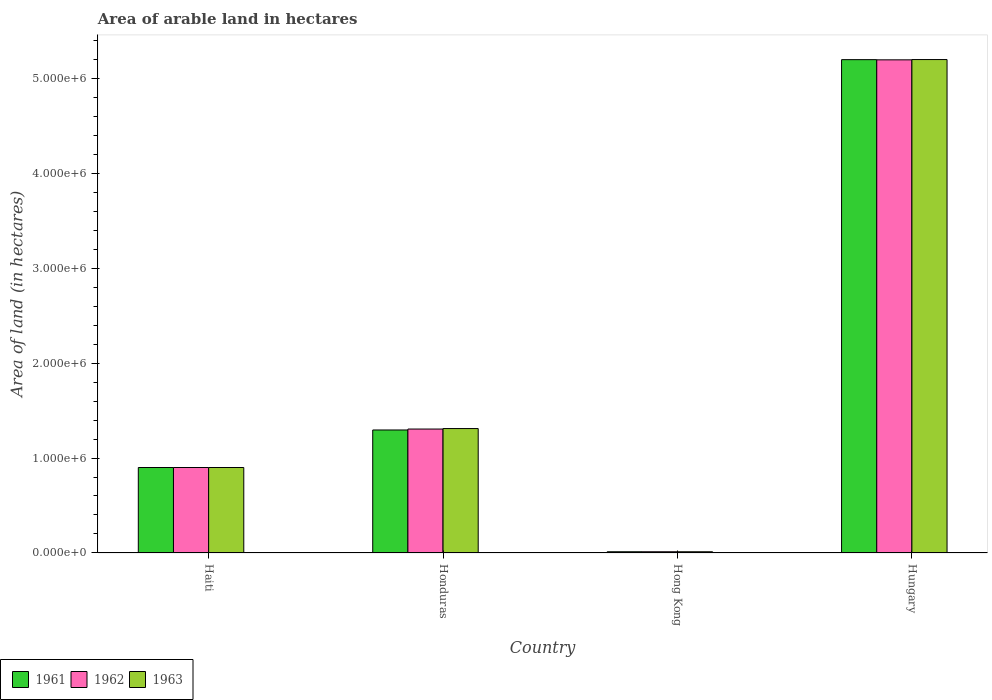How many different coloured bars are there?
Your answer should be very brief. 3. How many bars are there on the 4th tick from the left?
Ensure brevity in your answer.  3. What is the label of the 4th group of bars from the left?
Provide a short and direct response. Hungary. In how many cases, is the number of bars for a given country not equal to the number of legend labels?
Make the answer very short. 0. What is the total arable land in 1961 in Hong Kong?
Provide a succinct answer. 1.30e+04. Across all countries, what is the maximum total arable land in 1961?
Keep it short and to the point. 5.19e+06. Across all countries, what is the minimum total arable land in 1963?
Your answer should be very brief. 1.30e+04. In which country was the total arable land in 1963 maximum?
Provide a short and direct response. Hungary. In which country was the total arable land in 1961 minimum?
Your answer should be compact. Hong Kong. What is the total total arable land in 1961 in the graph?
Your answer should be very brief. 7.40e+06. What is the difference between the total arable land in 1961 in Hong Kong and that in Hungary?
Make the answer very short. -5.18e+06. What is the difference between the total arable land in 1962 in Hong Kong and the total arable land in 1961 in Hungary?
Your response must be concise. -5.18e+06. What is the average total arable land in 1962 per country?
Offer a terse response. 1.85e+06. What is the difference between the total arable land of/in 1961 and total arable land of/in 1963 in Hungary?
Your response must be concise. -1000. In how many countries, is the total arable land in 1963 greater than 2600000 hectares?
Ensure brevity in your answer.  1. What is the ratio of the total arable land in 1961 in Hong Kong to that in Hungary?
Offer a very short reply. 0. Is the total arable land in 1963 in Honduras less than that in Hungary?
Your answer should be very brief. Yes. What is the difference between the highest and the second highest total arable land in 1961?
Give a very brief answer. 3.90e+06. What is the difference between the highest and the lowest total arable land in 1962?
Offer a terse response. 5.18e+06. Is the sum of the total arable land in 1962 in Haiti and Hungary greater than the maximum total arable land in 1963 across all countries?
Give a very brief answer. Yes. What does the 2nd bar from the left in Hungary represents?
Ensure brevity in your answer.  1962. Is it the case that in every country, the sum of the total arable land in 1962 and total arable land in 1961 is greater than the total arable land in 1963?
Your answer should be compact. Yes. Are all the bars in the graph horizontal?
Your answer should be very brief. No. What is the difference between two consecutive major ticks on the Y-axis?
Provide a succinct answer. 1.00e+06. Does the graph contain grids?
Offer a terse response. No. How many legend labels are there?
Provide a succinct answer. 3. How are the legend labels stacked?
Your answer should be very brief. Horizontal. What is the title of the graph?
Your answer should be very brief. Area of arable land in hectares. What is the label or title of the X-axis?
Your answer should be very brief. Country. What is the label or title of the Y-axis?
Your answer should be very brief. Area of land (in hectares). What is the Area of land (in hectares) in 1962 in Haiti?
Your answer should be compact. 9.00e+05. What is the Area of land (in hectares) of 1961 in Honduras?
Your answer should be compact. 1.30e+06. What is the Area of land (in hectares) of 1962 in Honduras?
Provide a succinct answer. 1.30e+06. What is the Area of land (in hectares) of 1963 in Honduras?
Keep it short and to the point. 1.31e+06. What is the Area of land (in hectares) of 1961 in Hong Kong?
Offer a very short reply. 1.30e+04. What is the Area of land (in hectares) in 1962 in Hong Kong?
Offer a very short reply. 1.30e+04. What is the Area of land (in hectares) of 1963 in Hong Kong?
Give a very brief answer. 1.30e+04. What is the Area of land (in hectares) in 1961 in Hungary?
Ensure brevity in your answer.  5.19e+06. What is the Area of land (in hectares) in 1962 in Hungary?
Offer a very short reply. 5.19e+06. What is the Area of land (in hectares) in 1963 in Hungary?
Provide a short and direct response. 5.20e+06. Across all countries, what is the maximum Area of land (in hectares) in 1961?
Your answer should be very brief. 5.19e+06. Across all countries, what is the maximum Area of land (in hectares) in 1962?
Your answer should be very brief. 5.19e+06. Across all countries, what is the maximum Area of land (in hectares) of 1963?
Make the answer very short. 5.20e+06. Across all countries, what is the minimum Area of land (in hectares) of 1961?
Your response must be concise. 1.30e+04. Across all countries, what is the minimum Area of land (in hectares) of 1962?
Offer a terse response. 1.30e+04. Across all countries, what is the minimum Area of land (in hectares) in 1963?
Provide a succinct answer. 1.30e+04. What is the total Area of land (in hectares) in 1961 in the graph?
Keep it short and to the point. 7.40e+06. What is the total Area of land (in hectares) in 1962 in the graph?
Your answer should be compact. 7.41e+06. What is the total Area of land (in hectares) of 1963 in the graph?
Ensure brevity in your answer.  7.42e+06. What is the difference between the Area of land (in hectares) in 1961 in Haiti and that in Honduras?
Your answer should be compact. -3.95e+05. What is the difference between the Area of land (in hectares) of 1962 in Haiti and that in Honduras?
Your response must be concise. -4.05e+05. What is the difference between the Area of land (in hectares) in 1963 in Haiti and that in Honduras?
Your answer should be very brief. -4.10e+05. What is the difference between the Area of land (in hectares) in 1961 in Haiti and that in Hong Kong?
Give a very brief answer. 8.87e+05. What is the difference between the Area of land (in hectares) of 1962 in Haiti and that in Hong Kong?
Your response must be concise. 8.87e+05. What is the difference between the Area of land (in hectares) of 1963 in Haiti and that in Hong Kong?
Offer a terse response. 8.87e+05. What is the difference between the Area of land (in hectares) of 1961 in Haiti and that in Hungary?
Give a very brief answer. -4.29e+06. What is the difference between the Area of land (in hectares) in 1962 in Haiti and that in Hungary?
Provide a succinct answer. -4.29e+06. What is the difference between the Area of land (in hectares) of 1963 in Haiti and that in Hungary?
Provide a short and direct response. -4.30e+06. What is the difference between the Area of land (in hectares) in 1961 in Honduras and that in Hong Kong?
Make the answer very short. 1.28e+06. What is the difference between the Area of land (in hectares) of 1962 in Honduras and that in Hong Kong?
Your response must be concise. 1.29e+06. What is the difference between the Area of land (in hectares) of 1963 in Honduras and that in Hong Kong?
Your answer should be very brief. 1.30e+06. What is the difference between the Area of land (in hectares) of 1961 in Honduras and that in Hungary?
Offer a terse response. -3.90e+06. What is the difference between the Area of land (in hectares) in 1962 in Honduras and that in Hungary?
Your response must be concise. -3.89e+06. What is the difference between the Area of land (in hectares) of 1963 in Honduras and that in Hungary?
Offer a very short reply. -3.88e+06. What is the difference between the Area of land (in hectares) of 1961 in Hong Kong and that in Hungary?
Offer a terse response. -5.18e+06. What is the difference between the Area of land (in hectares) in 1962 in Hong Kong and that in Hungary?
Provide a short and direct response. -5.18e+06. What is the difference between the Area of land (in hectares) of 1963 in Hong Kong and that in Hungary?
Make the answer very short. -5.18e+06. What is the difference between the Area of land (in hectares) in 1961 in Haiti and the Area of land (in hectares) in 1962 in Honduras?
Your answer should be very brief. -4.05e+05. What is the difference between the Area of land (in hectares) in 1961 in Haiti and the Area of land (in hectares) in 1963 in Honduras?
Offer a very short reply. -4.10e+05. What is the difference between the Area of land (in hectares) of 1962 in Haiti and the Area of land (in hectares) of 1963 in Honduras?
Make the answer very short. -4.10e+05. What is the difference between the Area of land (in hectares) in 1961 in Haiti and the Area of land (in hectares) in 1962 in Hong Kong?
Offer a very short reply. 8.87e+05. What is the difference between the Area of land (in hectares) of 1961 in Haiti and the Area of land (in hectares) of 1963 in Hong Kong?
Offer a very short reply. 8.87e+05. What is the difference between the Area of land (in hectares) of 1962 in Haiti and the Area of land (in hectares) of 1963 in Hong Kong?
Your answer should be very brief. 8.87e+05. What is the difference between the Area of land (in hectares) of 1961 in Haiti and the Area of land (in hectares) of 1962 in Hungary?
Keep it short and to the point. -4.29e+06. What is the difference between the Area of land (in hectares) of 1961 in Haiti and the Area of land (in hectares) of 1963 in Hungary?
Keep it short and to the point. -4.30e+06. What is the difference between the Area of land (in hectares) of 1962 in Haiti and the Area of land (in hectares) of 1963 in Hungary?
Provide a succinct answer. -4.30e+06. What is the difference between the Area of land (in hectares) of 1961 in Honduras and the Area of land (in hectares) of 1962 in Hong Kong?
Make the answer very short. 1.28e+06. What is the difference between the Area of land (in hectares) of 1961 in Honduras and the Area of land (in hectares) of 1963 in Hong Kong?
Offer a terse response. 1.28e+06. What is the difference between the Area of land (in hectares) of 1962 in Honduras and the Area of land (in hectares) of 1963 in Hong Kong?
Give a very brief answer. 1.29e+06. What is the difference between the Area of land (in hectares) in 1961 in Honduras and the Area of land (in hectares) in 1962 in Hungary?
Your response must be concise. -3.90e+06. What is the difference between the Area of land (in hectares) of 1961 in Honduras and the Area of land (in hectares) of 1963 in Hungary?
Give a very brief answer. -3.90e+06. What is the difference between the Area of land (in hectares) in 1962 in Honduras and the Area of land (in hectares) in 1963 in Hungary?
Provide a succinct answer. -3.89e+06. What is the difference between the Area of land (in hectares) in 1961 in Hong Kong and the Area of land (in hectares) in 1962 in Hungary?
Your answer should be compact. -5.18e+06. What is the difference between the Area of land (in hectares) of 1961 in Hong Kong and the Area of land (in hectares) of 1963 in Hungary?
Provide a short and direct response. -5.18e+06. What is the difference between the Area of land (in hectares) of 1962 in Hong Kong and the Area of land (in hectares) of 1963 in Hungary?
Keep it short and to the point. -5.18e+06. What is the average Area of land (in hectares) in 1961 per country?
Offer a very short reply. 1.85e+06. What is the average Area of land (in hectares) of 1962 per country?
Keep it short and to the point. 1.85e+06. What is the average Area of land (in hectares) of 1963 per country?
Make the answer very short. 1.85e+06. What is the difference between the Area of land (in hectares) of 1961 and Area of land (in hectares) of 1963 in Honduras?
Provide a succinct answer. -1.50e+04. What is the difference between the Area of land (in hectares) of 1962 and Area of land (in hectares) of 1963 in Honduras?
Your answer should be very brief. -5000. What is the difference between the Area of land (in hectares) of 1961 and Area of land (in hectares) of 1962 in Hong Kong?
Give a very brief answer. 0. What is the difference between the Area of land (in hectares) of 1962 and Area of land (in hectares) of 1963 in Hong Kong?
Your answer should be compact. 0. What is the difference between the Area of land (in hectares) of 1961 and Area of land (in hectares) of 1963 in Hungary?
Give a very brief answer. -1000. What is the difference between the Area of land (in hectares) of 1962 and Area of land (in hectares) of 1963 in Hungary?
Your answer should be compact. -3000. What is the ratio of the Area of land (in hectares) in 1961 in Haiti to that in Honduras?
Your response must be concise. 0.69. What is the ratio of the Area of land (in hectares) in 1962 in Haiti to that in Honduras?
Your answer should be very brief. 0.69. What is the ratio of the Area of land (in hectares) in 1963 in Haiti to that in Honduras?
Make the answer very short. 0.69. What is the ratio of the Area of land (in hectares) in 1961 in Haiti to that in Hong Kong?
Your answer should be compact. 69.23. What is the ratio of the Area of land (in hectares) in 1962 in Haiti to that in Hong Kong?
Your answer should be very brief. 69.23. What is the ratio of the Area of land (in hectares) of 1963 in Haiti to that in Hong Kong?
Your answer should be very brief. 69.23. What is the ratio of the Area of land (in hectares) of 1961 in Haiti to that in Hungary?
Keep it short and to the point. 0.17. What is the ratio of the Area of land (in hectares) in 1962 in Haiti to that in Hungary?
Provide a short and direct response. 0.17. What is the ratio of the Area of land (in hectares) in 1963 in Haiti to that in Hungary?
Offer a terse response. 0.17. What is the ratio of the Area of land (in hectares) of 1961 in Honduras to that in Hong Kong?
Your response must be concise. 99.62. What is the ratio of the Area of land (in hectares) of 1962 in Honduras to that in Hong Kong?
Make the answer very short. 100.38. What is the ratio of the Area of land (in hectares) of 1963 in Honduras to that in Hong Kong?
Give a very brief answer. 100.77. What is the ratio of the Area of land (in hectares) in 1961 in Honduras to that in Hungary?
Keep it short and to the point. 0.25. What is the ratio of the Area of land (in hectares) of 1962 in Honduras to that in Hungary?
Your answer should be very brief. 0.25. What is the ratio of the Area of land (in hectares) in 1963 in Honduras to that in Hungary?
Offer a terse response. 0.25. What is the ratio of the Area of land (in hectares) of 1961 in Hong Kong to that in Hungary?
Your answer should be very brief. 0. What is the ratio of the Area of land (in hectares) in 1962 in Hong Kong to that in Hungary?
Your answer should be compact. 0. What is the ratio of the Area of land (in hectares) in 1963 in Hong Kong to that in Hungary?
Your answer should be very brief. 0. What is the difference between the highest and the second highest Area of land (in hectares) of 1961?
Offer a terse response. 3.90e+06. What is the difference between the highest and the second highest Area of land (in hectares) of 1962?
Give a very brief answer. 3.89e+06. What is the difference between the highest and the second highest Area of land (in hectares) in 1963?
Provide a short and direct response. 3.88e+06. What is the difference between the highest and the lowest Area of land (in hectares) of 1961?
Make the answer very short. 5.18e+06. What is the difference between the highest and the lowest Area of land (in hectares) in 1962?
Provide a succinct answer. 5.18e+06. What is the difference between the highest and the lowest Area of land (in hectares) of 1963?
Your answer should be compact. 5.18e+06. 